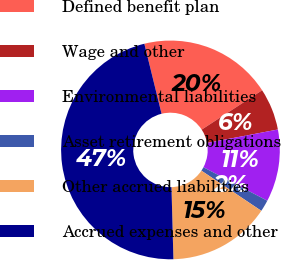Convert chart. <chart><loc_0><loc_0><loc_500><loc_500><pie_chart><fcel>Defined benefit plan<fcel>Wage and other<fcel>Environmental liabilities<fcel>Asset retirement obligations<fcel>Other accrued liabilities<fcel>Accrued expenses and other<nl><fcel>19.66%<fcel>6.19%<fcel>10.68%<fcel>1.71%<fcel>15.17%<fcel>46.59%<nl></chart> 